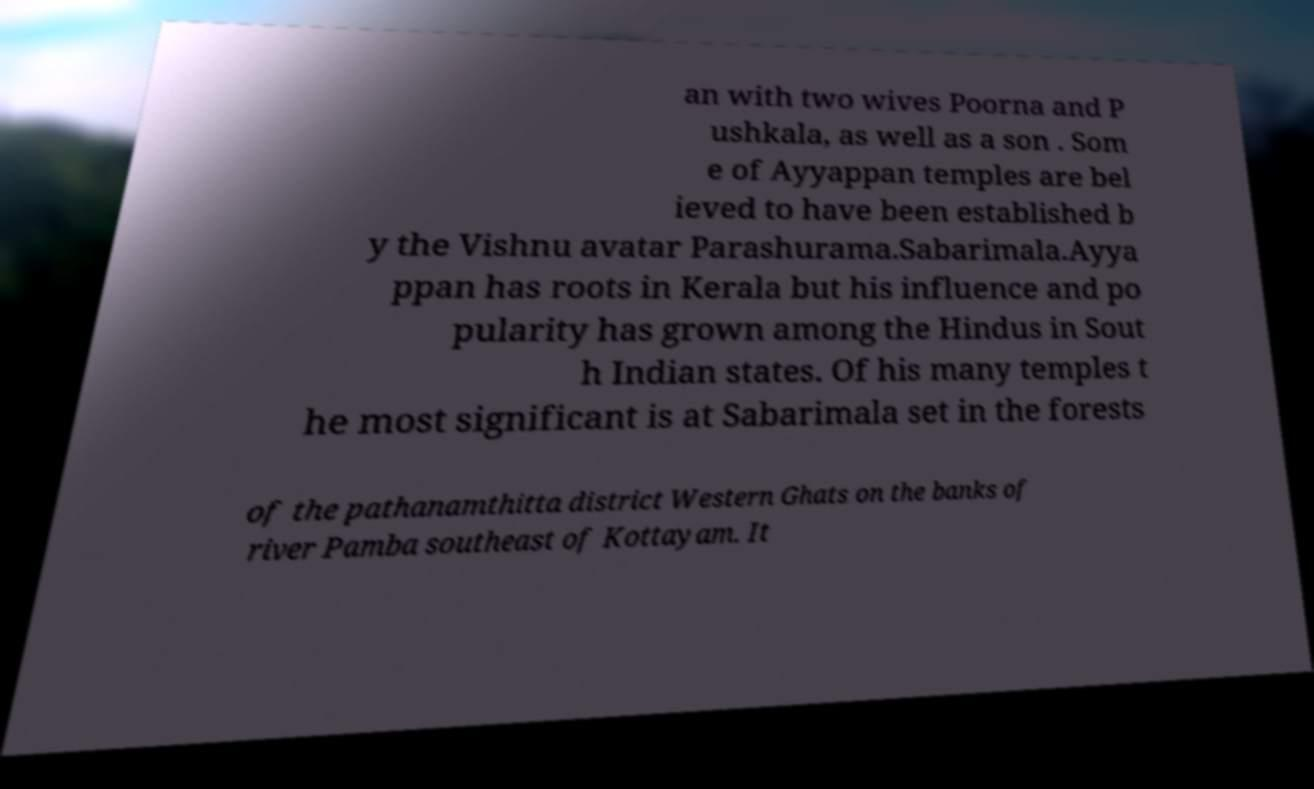I need the written content from this picture converted into text. Can you do that? an with two wives Poorna and P ushkala, as well as a son . Som e of Ayyappan temples are bel ieved to have been established b y the Vishnu avatar Parashurama.Sabarimala.Ayya ppan has roots in Kerala but his influence and po pularity has grown among the Hindus in Sout h Indian states. Of his many temples t he most significant is at Sabarimala set in the forests of the pathanamthitta district Western Ghats on the banks of river Pamba southeast of Kottayam. It 